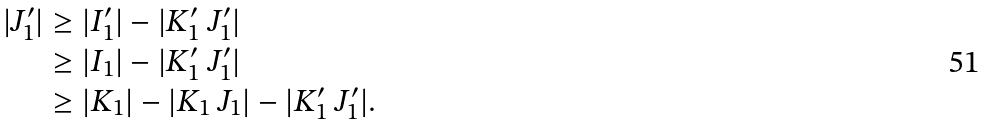Convert formula to latex. <formula><loc_0><loc_0><loc_500><loc_500>| J _ { 1 } ^ { \prime } | & \geq | I _ { 1 } ^ { \prime } | - | K _ { 1 } ^ { \prime } \ J _ { 1 } ^ { \prime } | \\ & \geq | I _ { 1 } | - | K _ { 1 } ^ { \prime } \ J _ { 1 } ^ { \prime } | \\ & \geq | K _ { 1 } | - | K _ { 1 } \ J _ { 1 } | - | K _ { 1 } ^ { \prime } \ J _ { 1 } ^ { \prime } | .</formula> 